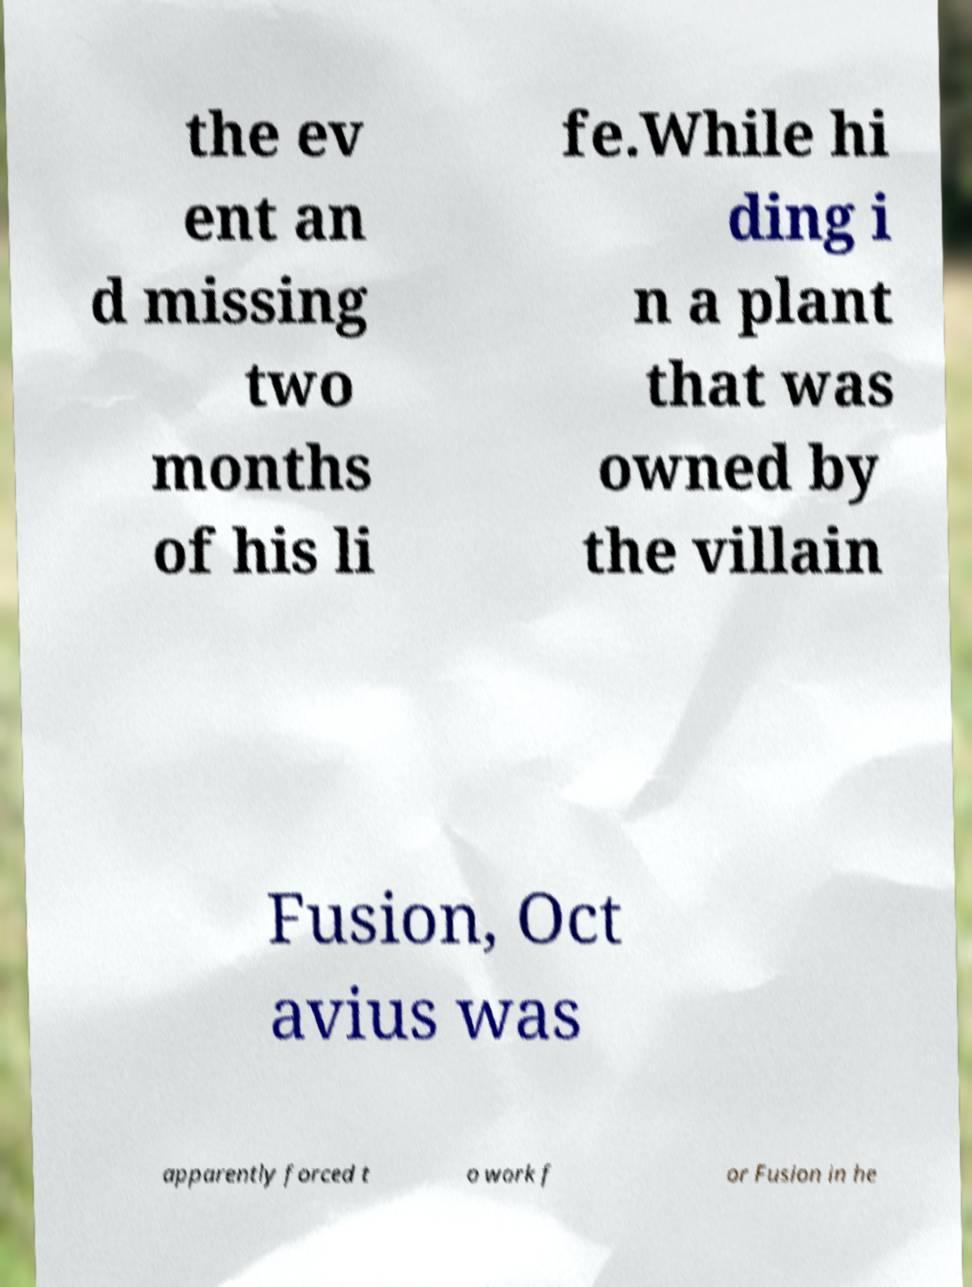Could you assist in decoding the text presented in this image and type it out clearly? the ev ent an d missing two months of his li fe.While hi ding i n a plant that was owned by the villain Fusion, Oct avius was apparently forced t o work f or Fusion in he 